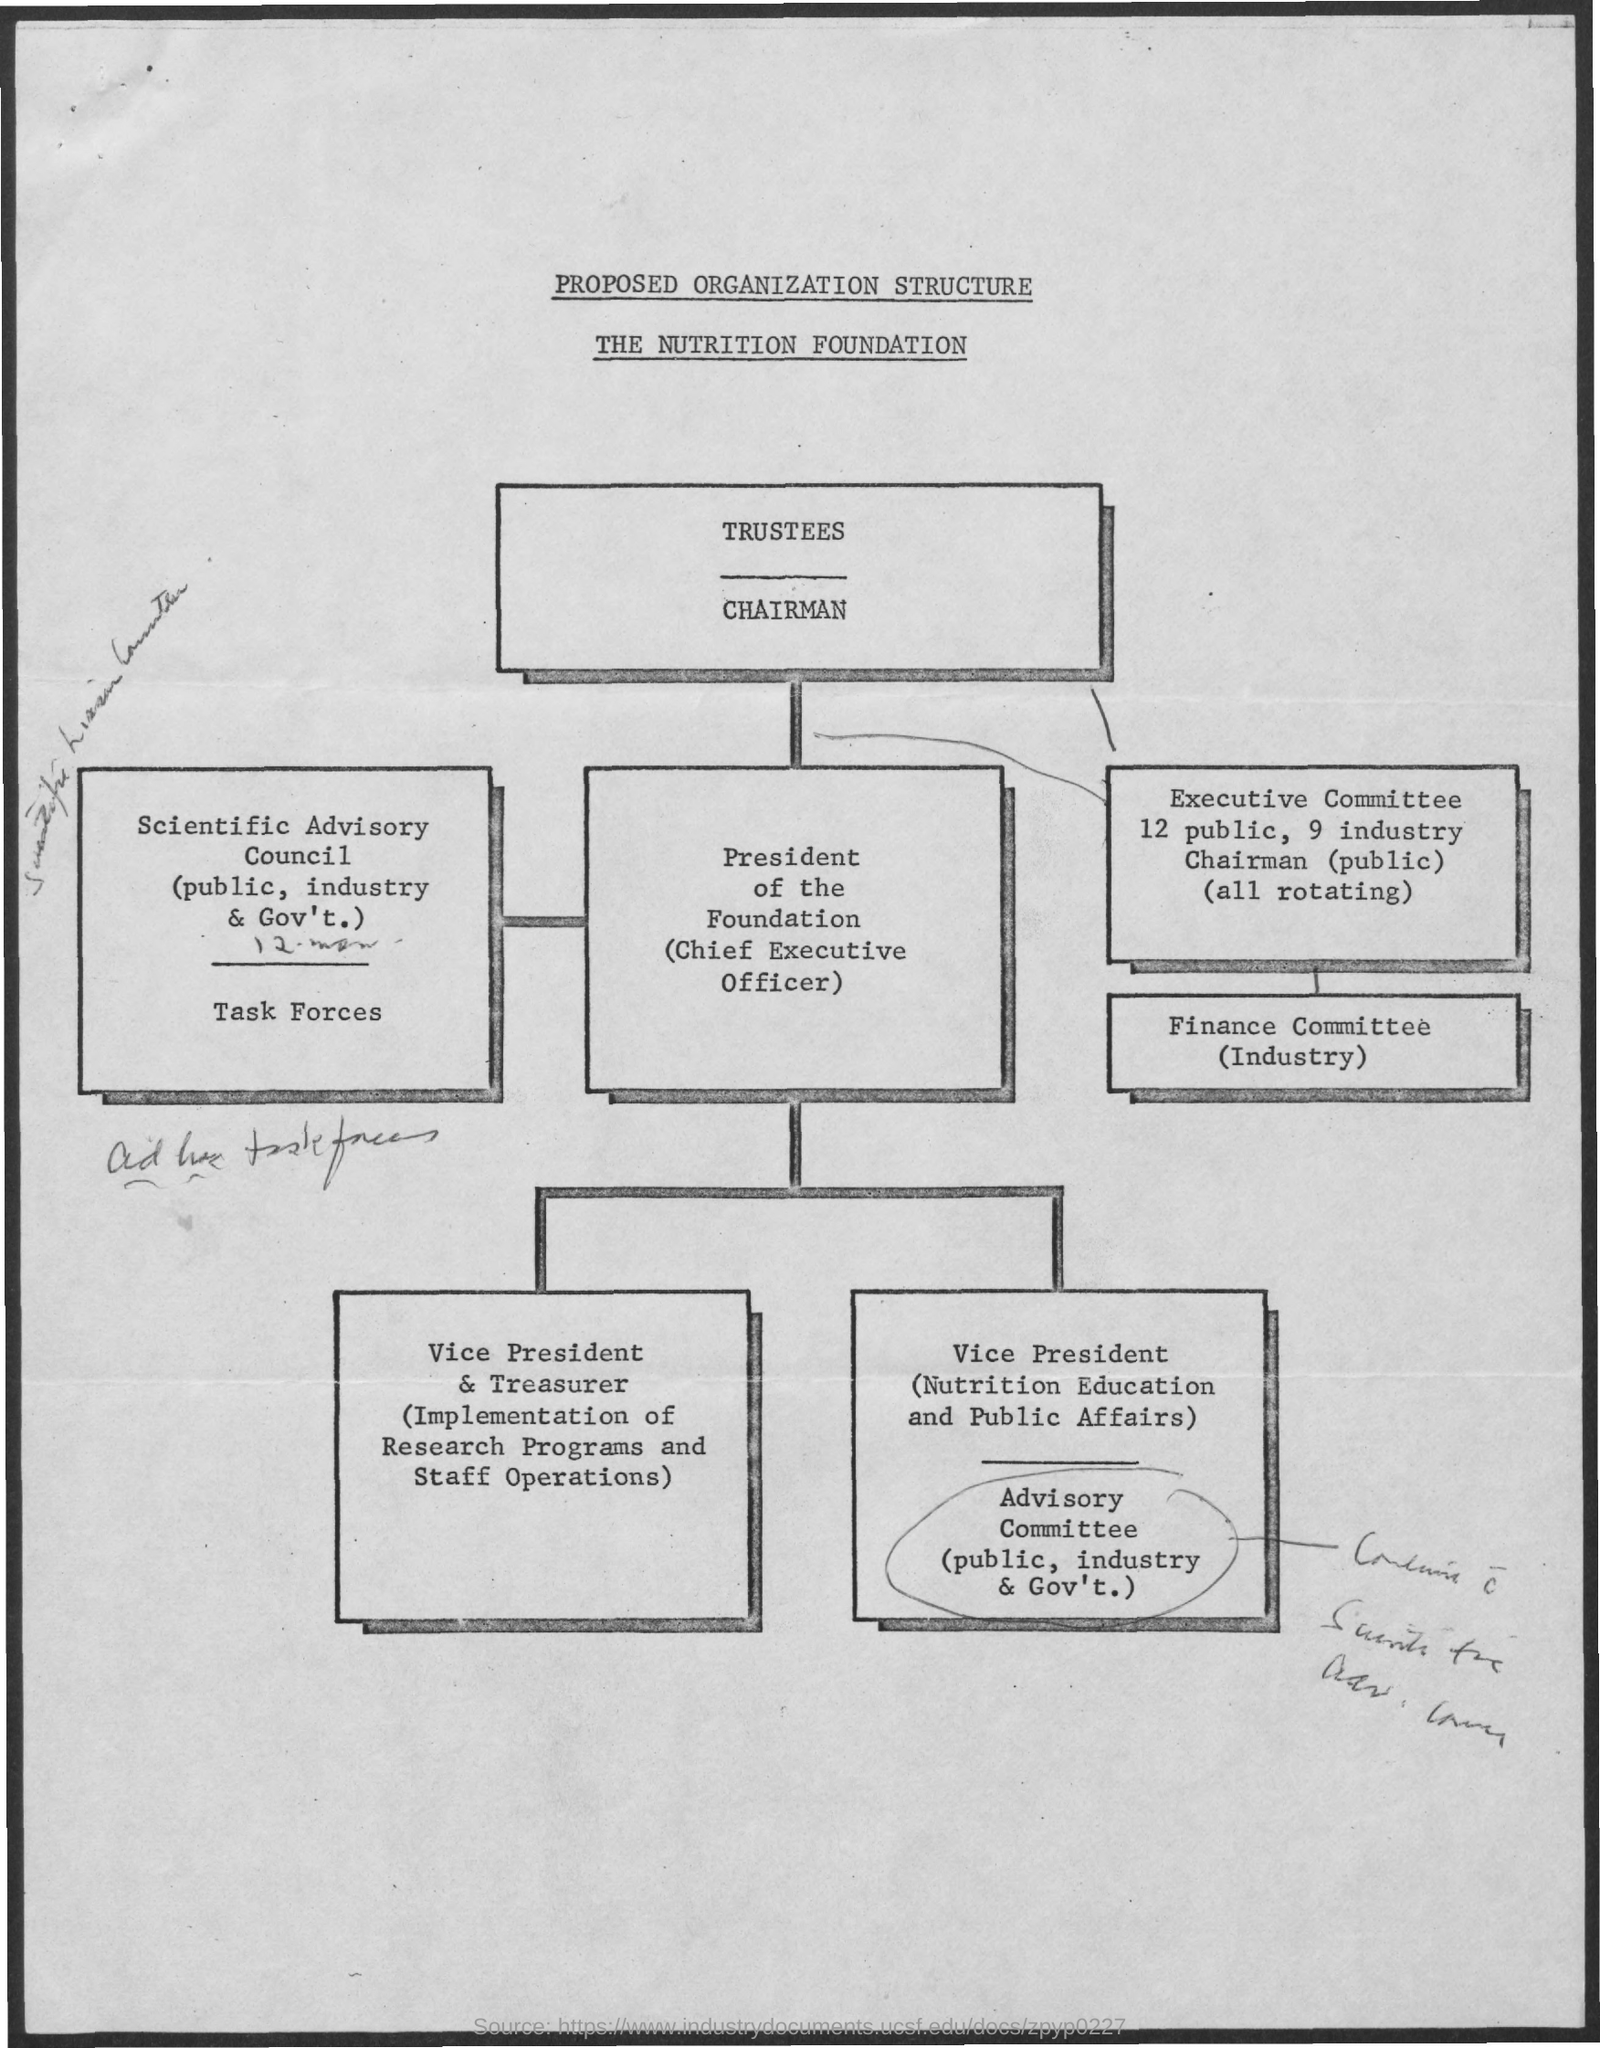Give some essential details in this illustration. The Vice President and Treasurer is responsible for overseeing the implementation of research programs and staff operations. This document outlines the proposed organization structure of The Nutrition Foundation. 